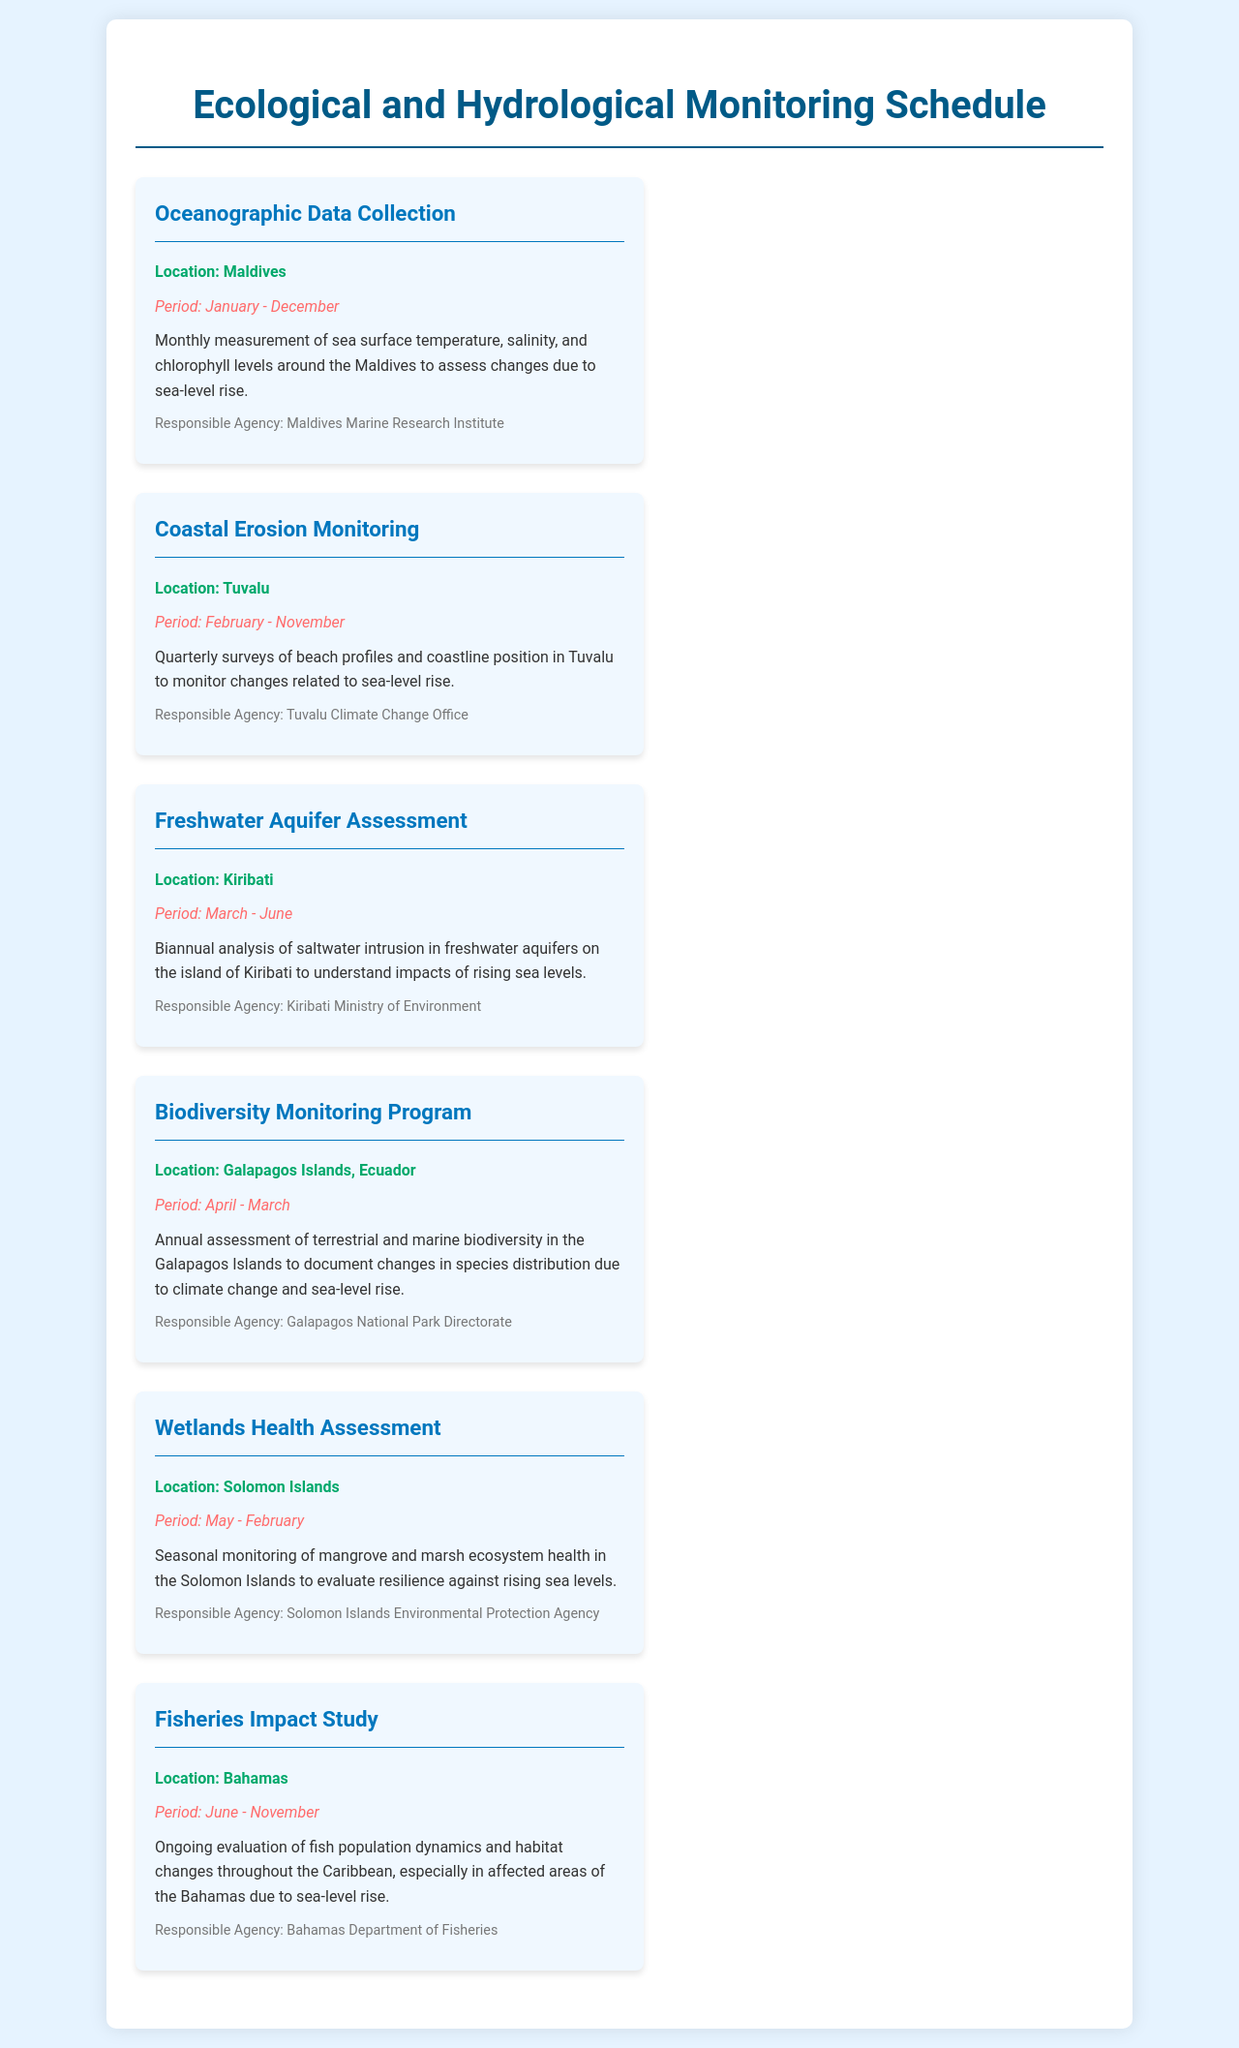what is the duration of the Oceanographic Data Collection activity? The duration is stated as "January - December" in the document.
Answer: January - December which agency is responsible for the Coastal Erosion Monitoring in Tuvalu? The agency responsible is mentioned as "Tuvalu Climate Change Office" in the document.
Answer: Tuvalu Climate Change Office how often are surveys conducted for the Freshwater Aquifer Assessment in Kiribati? The document states it is conducted biannually, which means twice a year.
Answer: Biannual what is the main focus of the Biodiversity Monitoring Program in the Galapagos Islands? The focus is on "annual assessment of terrestrial and marine biodiversity" as noted in the document.
Answer: Biodiversity assessment when does the Wetlands Health Assessment take place? The document specifies that it occurs from "May - February."
Answer: May - February what is the purpose of the Fisheries Impact Study in the Bahamas? The purpose is described as the evaluation of "fish population dynamics and habitat changes," according to the document.
Answer: Fish population dynamics and habitat changes which island nation is assessed for saltwater intrusion during the Freshwater Aquifer Assessment? The document mentions "Kiribati" as the location of this assessment.
Answer: Kiribati what is the period for the Coastal Erosion Monitoring activity? The period specified in the document is "February - November."
Answer: February - November 